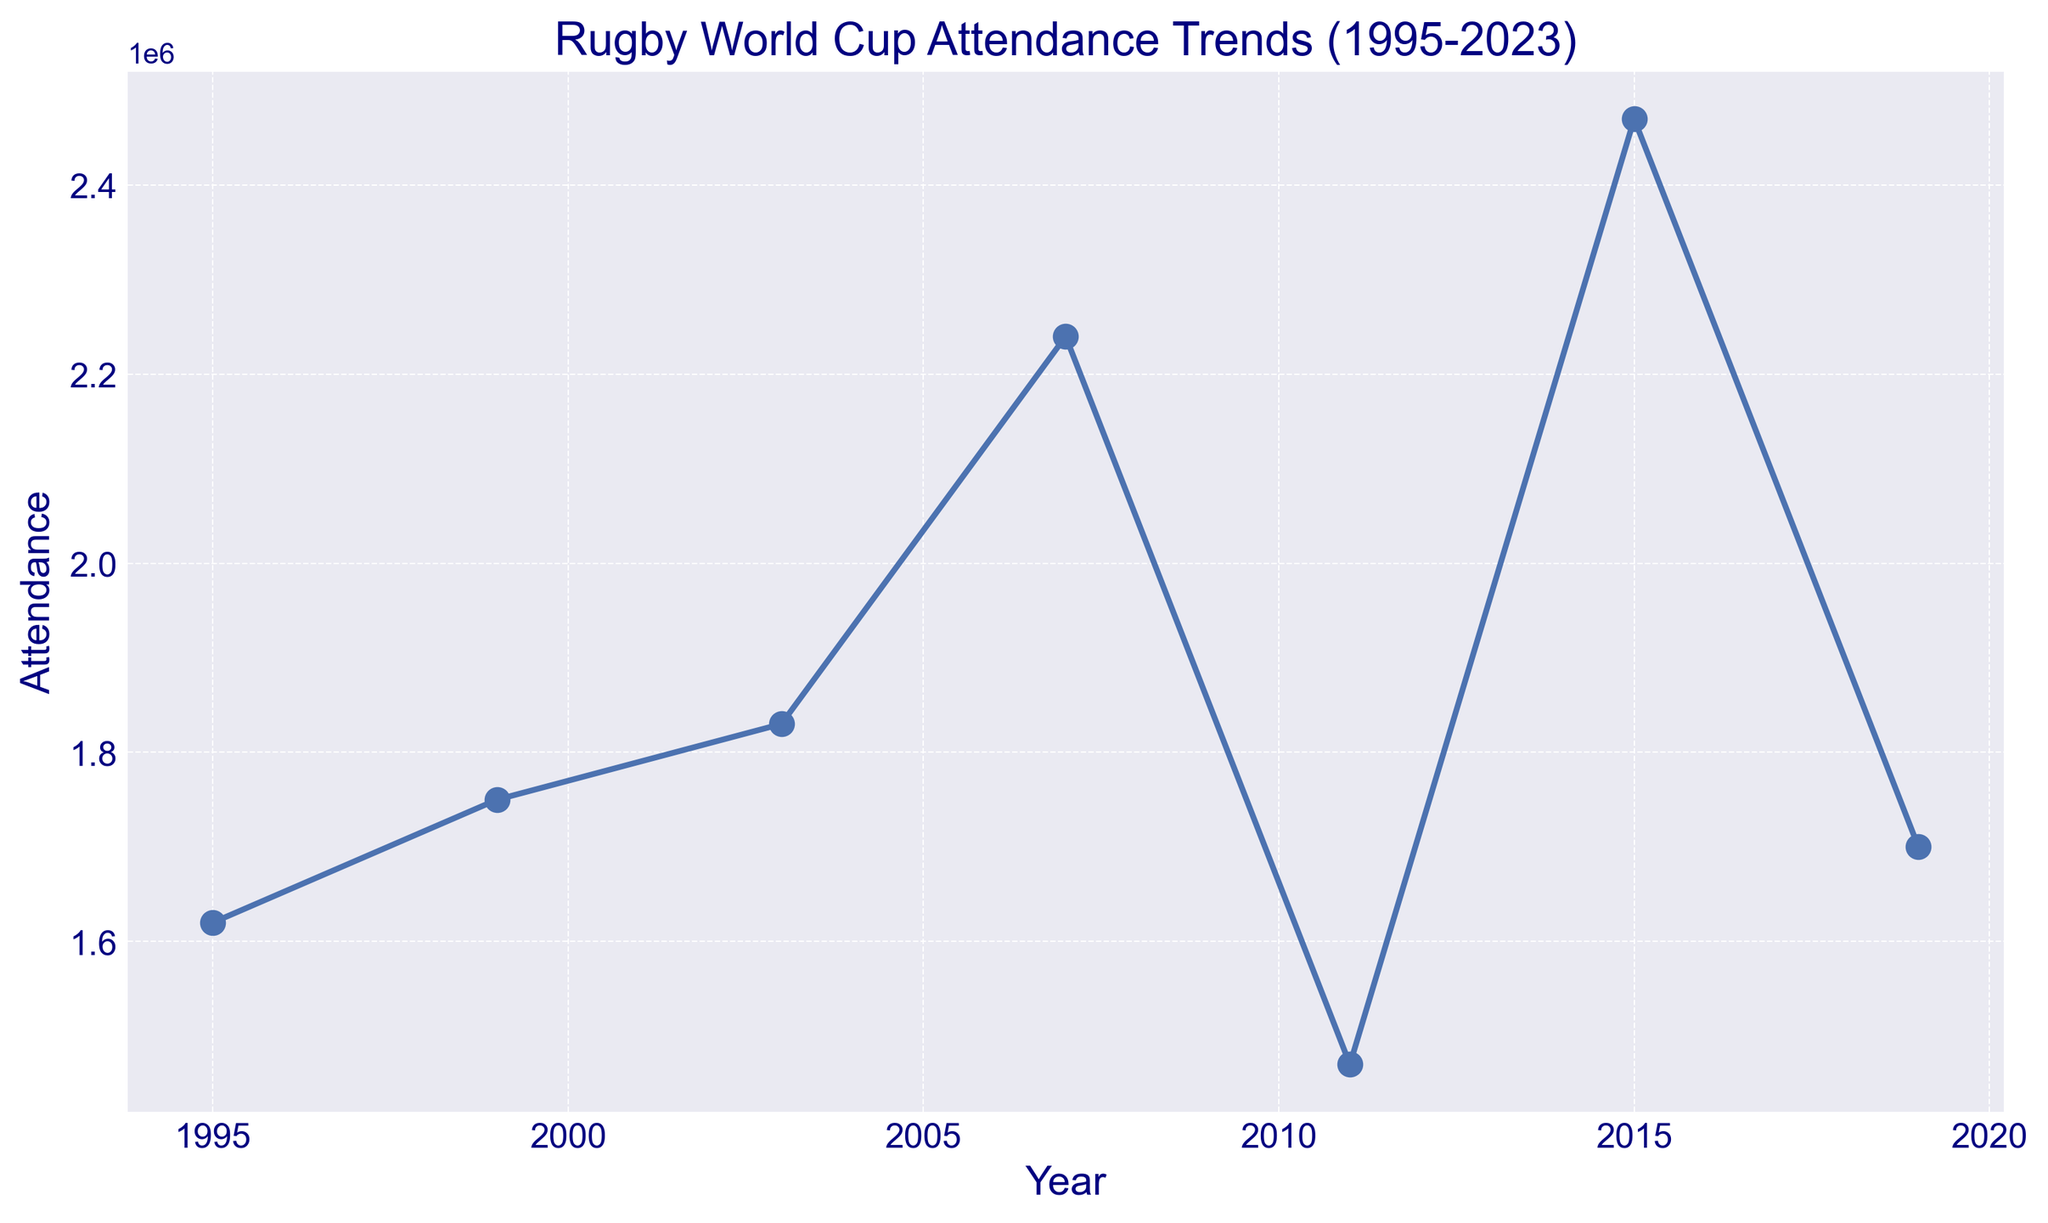What year had the highest Rugby World Cup attendance? Looking at the plot, the year with the highest point on the y-axis (attendance) is 2015. The label reads 2,470,000.
Answer: 2015 How does the attendance in 2019 compare to the attendance in 1999? On the plot, 1999 has an attendance of 1,750,000 and 2019 has an attendance of 1,700,000. 2019's attendance is slightly lower than 1999's.
Answer: 2019 is slightly lower Which World Cup had a greater increase in attendance from the previous tournament, 2003 or 2007? From the plot, 1999 to 2003 shows an increase from 1,750,000 to 1,830,000 (an increase of 80,000). From 2003 to 2007, the attendance increased from 1,830,000 to 2,240,000 (an increase of 410,000). So, 2007 had a greater increase.
Answer: 2007 What is the average attendance from 1995 to 2019? Summing the attendance values: 1,620,000 + 1,750,000 + 1,830,000 + 2,240,000 + 1,470,000 + 2,470,000 + 1,700,000 = 12,080,000. There are 7 data points, dividing by 7: 12,080,000 / 7 = 1,725,714.
Answer: 1,725,714 Between which two consecutive tournaments was the greatest decrease in attendance? Looking at the plot, the biggest drop occurs between 2007 (2,240,000) and 2011 (1,470,000). The decrease is 2,240,000 - 1,470,000 = 770,000.
Answer: 2007 and 2011 What is the trend of the attendance from 1995 to 2023? The plot shows points starting from 1995 rising gradually to 2015, peaking, then a slight drop in 2019, and an undefined value for 2023. Generally, there is an upward trend followed by a slight decrease.
Answer: Increasing trend with a slight decrease How did the attendance change between the 2007 and 2011 World Cups? The plot shows attendance in 2007 was 2,240,000 and it dropped to 1,470,000 in 2011. The change is a decrease of 770,000.
Answer: Decrease of 770,000 What has been the general visual trend in Rugby World Cup attendance since 2011? Visually, after a significant drop in 2011, there is a sharp increase in 2015, followed by a slight decrease in 2019.
Answer: Increased then slightly decreased What's the approximate average attendance from 2007 to 2019? Summing the attendances: 2,240,000 + 1,470,000 + 2,470,000 + 1,700,000 = 7,880,000. Dividing by 4 gives approximately: 7,880,000 / 4 = 1,970,000.
Answer: 1,970,000 